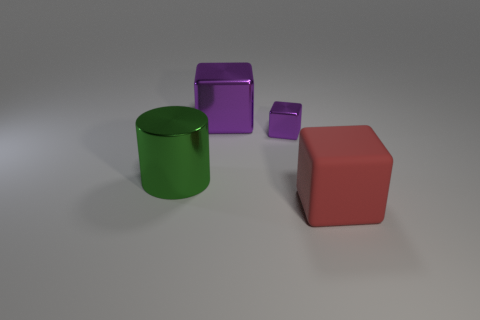Add 3 large red blocks. How many objects exist? 7 Subtract all cylinders. How many objects are left? 3 Subtract all rubber objects. Subtract all cyan metal spheres. How many objects are left? 3 Add 4 small objects. How many small objects are left? 5 Add 3 big shiny cylinders. How many big shiny cylinders exist? 4 Subtract 0 gray cylinders. How many objects are left? 4 